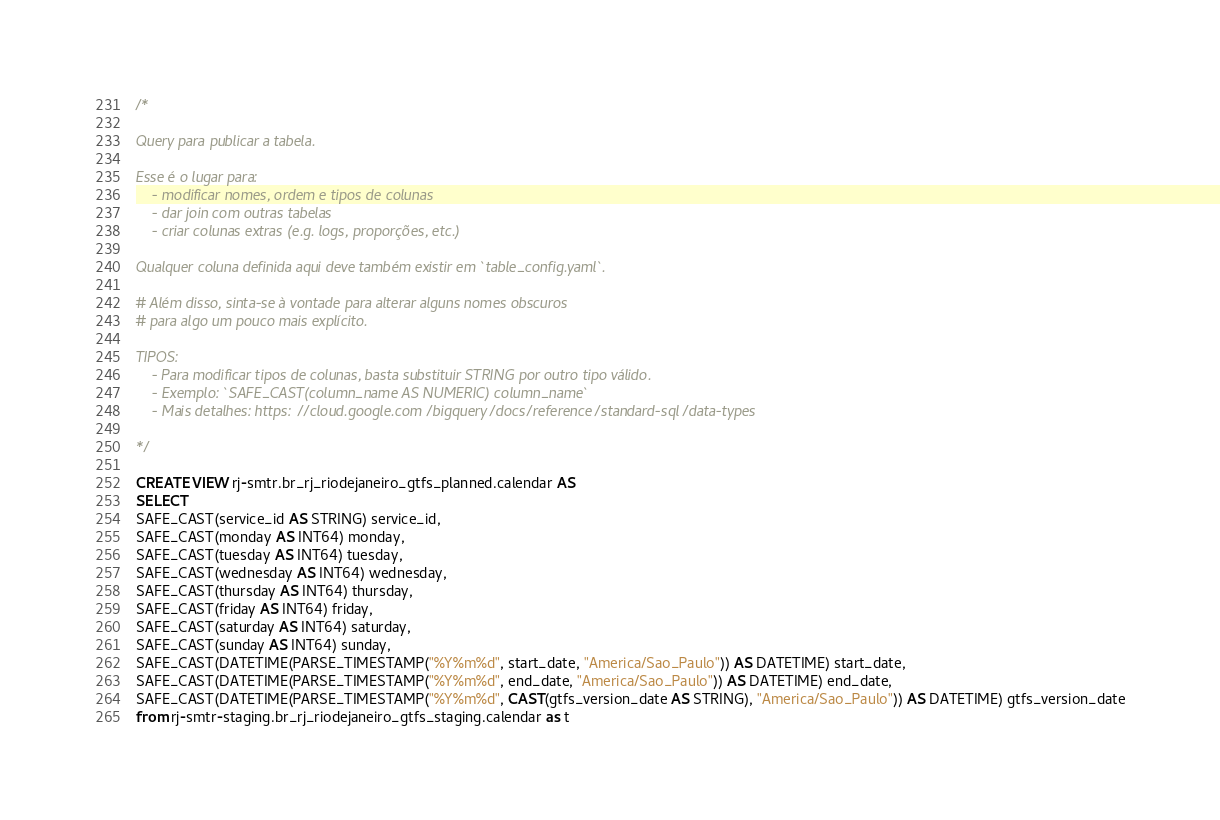Convert code to text. <code><loc_0><loc_0><loc_500><loc_500><_SQL_>/*

Query para publicar a tabela.

Esse é o lugar para:
    - modificar nomes, ordem e tipos de colunas
    - dar join com outras tabelas
    - criar colunas extras (e.g. logs, proporções, etc.)

Qualquer coluna definida aqui deve também existir em `table_config.yaml`.

# Além disso, sinta-se à vontade para alterar alguns nomes obscuros
# para algo um pouco mais explícito.

TIPOS:
    - Para modificar tipos de colunas, basta substituir STRING por outro tipo válido.
    - Exemplo: `SAFE_CAST(column_name AS NUMERIC) column_name`
    - Mais detalhes: https://cloud.google.com/bigquery/docs/reference/standard-sql/data-types

*/

CREATE VIEW rj-smtr.br_rj_riodejaneiro_gtfs_planned.calendar AS
SELECT 
SAFE_CAST(service_id AS STRING) service_id,
SAFE_CAST(monday AS INT64) monday,
SAFE_CAST(tuesday AS INT64) tuesday,
SAFE_CAST(wednesday AS INT64) wednesday,
SAFE_CAST(thursday AS INT64) thursday,
SAFE_CAST(friday AS INT64) friday,
SAFE_CAST(saturday AS INT64) saturday,
SAFE_CAST(sunday AS INT64) sunday,
SAFE_CAST(DATETIME(PARSE_TIMESTAMP("%Y%m%d", start_date, "America/Sao_Paulo")) AS DATETIME) start_date,
SAFE_CAST(DATETIME(PARSE_TIMESTAMP("%Y%m%d", end_date, "America/Sao_Paulo")) AS DATETIME) end_date,
SAFE_CAST(DATETIME(PARSE_TIMESTAMP("%Y%m%d", CAST(gtfs_version_date AS STRING), "America/Sao_Paulo")) AS DATETIME) gtfs_version_date
from rj-smtr-staging.br_rj_riodejaneiro_gtfs_staging.calendar as t</code> 